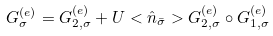<formula> <loc_0><loc_0><loc_500><loc_500>G _ { \sigma } ^ { ( e ) } = G _ { 2 , \sigma } ^ { ( e ) } + U < \hat { n } _ { \bar { \sigma } } > G _ { 2 , \sigma } ^ { ( e ) } \circ G _ { 1 , \sigma } ^ { ( e ) }</formula> 